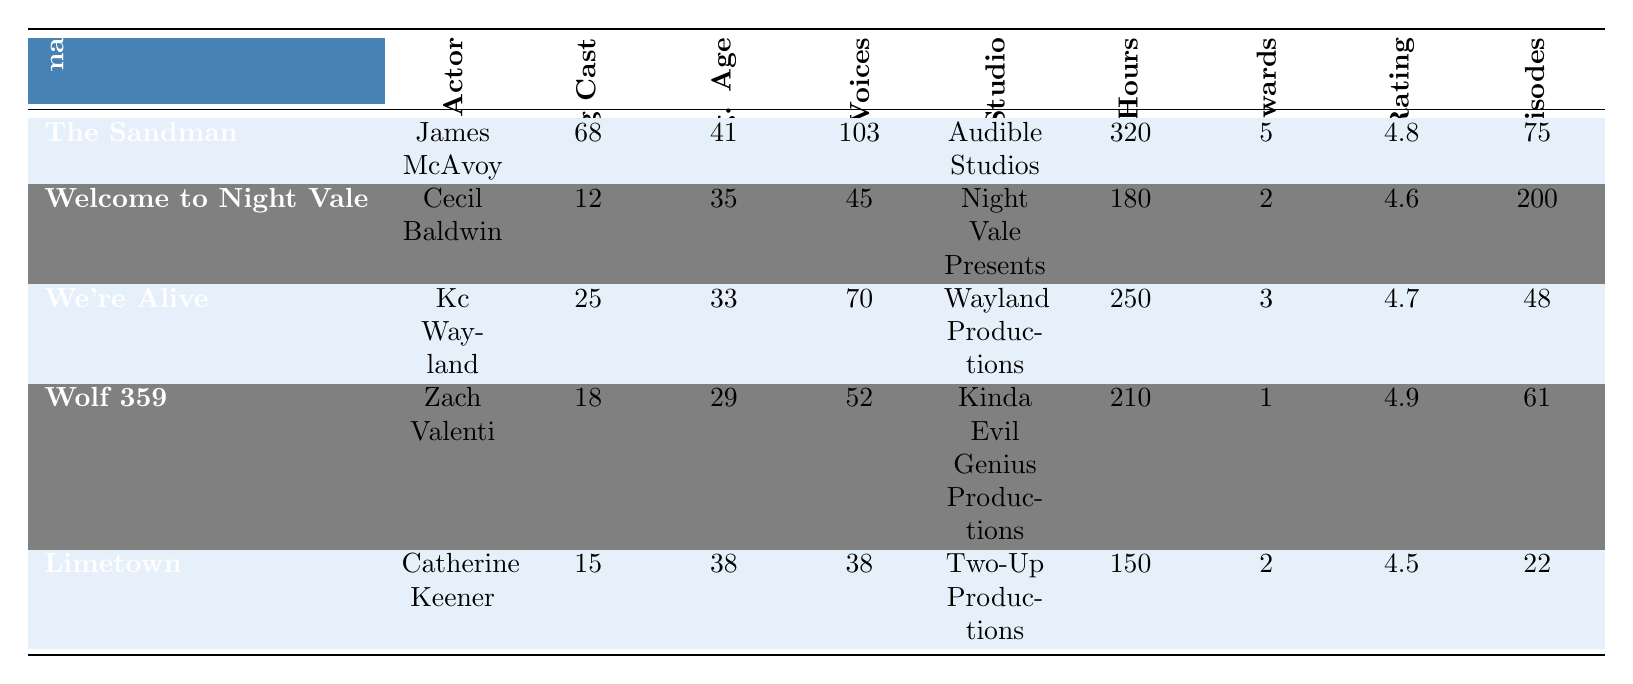What is the lead actor for "Wolf 359"? According to the table, the lead actor for "Wolf 359" is Zach Valenti.
Answer: Zach Valenti How many total recording hours did "Welcome to Night Vale" take? The table shows that the total recording hours for "Welcome to Night Vale" is 180.
Answer: 180 What is the average age of the cast in "The Sandman"? The average age of the cast in "The Sandman" is provided in the table as 41 years.
Answer: 41 Which audio drama has the highest number of distinct character voices? The table indicates that "The Sandman" has the highest number of distinct character voices, which is 103.
Answer: The Sandman How many episodes does "Limetown" have compared to "We're Alive"? "Limetown" has 22 episodes and "We're Alive" has 48 episodes. The difference is 48 - 22 = 26 fewer episodes in "Limetown."
Answer: 26 What is the average listener rating for the audio dramas? To find the average, sum the listener ratings (4.8 + 4.6 + 4.7 + 4.9 + 4.5 = 24.5) and divide by the number of dramas (5), resulting in an average of 24.5 / 5 = 4.9.
Answer: 4.9 Does "We're Alive" have more awards than "Limetown"? "We're Alive" has 3 awards and "Limetown" has 2 awards, thus "We're Alive" has more awards.
Answer: Yes Which audio drama has the highest average age of the cast? The table shows that "The Sandman" has the highest average age at 41 years, compared to other dramas.
Answer: The Sandman What is the difference in the number of supporting cast members between "Welcome to Night Vale" and "Wolf 359"? "Welcome to Night Vale" has 12 supporting cast members while "Wolf 359" has 18, leading to a difference of 18 - 12 = 6 more supporting cast members in "Wolf 359."
Answer: 6 Is the total recording hours for "We're Alive" more than the average of total recording hours for all dramas? The average total recording hours is (320 + 180 + 250 + 210 + 150) / 5 = 222. "We're Alive" has 250 hours, which is greater than the average.
Answer: Yes 